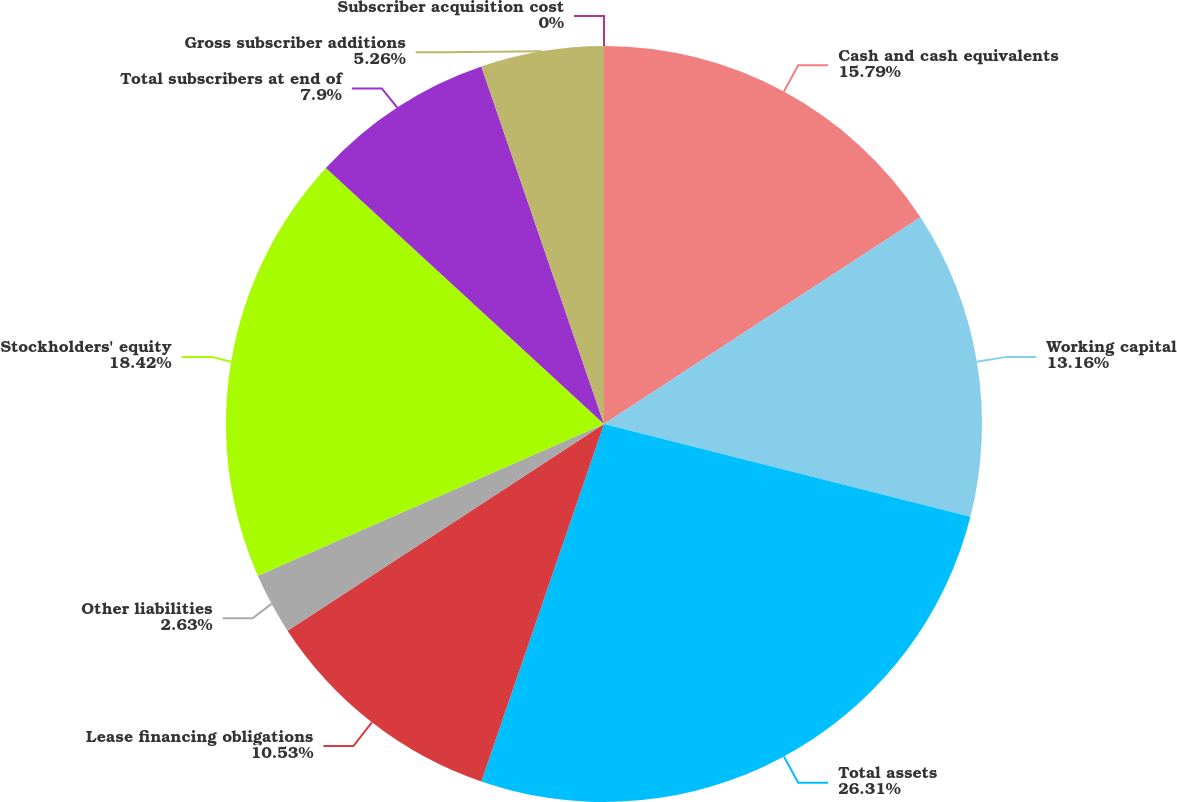Convert chart to OTSL. <chart><loc_0><loc_0><loc_500><loc_500><pie_chart><fcel>Cash and cash equivalents<fcel>Working capital<fcel>Total assets<fcel>Lease financing obligations<fcel>Other liabilities<fcel>Stockholders' equity<fcel>Total subscribers at end of<fcel>Gross subscriber additions<fcel>Subscriber acquisition cost<nl><fcel>15.79%<fcel>13.16%<fcel>26.31%<fcel>10.53%<fcel>2.63%<fcel>18.42%<fcel>7.9%<fcel>5.26%<fcel>0.0%<nl></chart> 